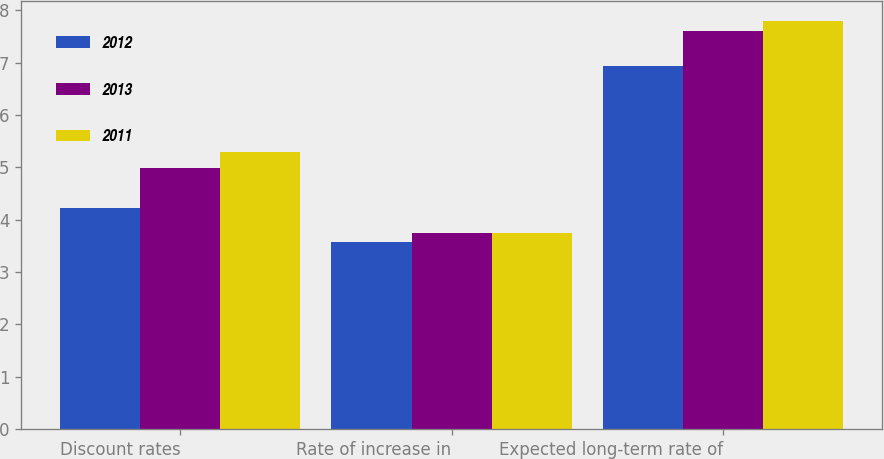Convert chart. <chart><loc_0><loc_0><loc_500><loc_500><stacked_bar_chart><ecel><fcel>Discount rates<fcel>Rate of increase in<fcel>Expected long-term rate of<nl><fcel>2012<fcel>4.22<fcel>3.58<fcel>6.94<nl><fcel>2013<fcel>4.98<fcel>3.74<fcel>7.6<nl><fcel>2011<fcel>5.3<fcel>3.75<fcel>7.79<nl></chart> 